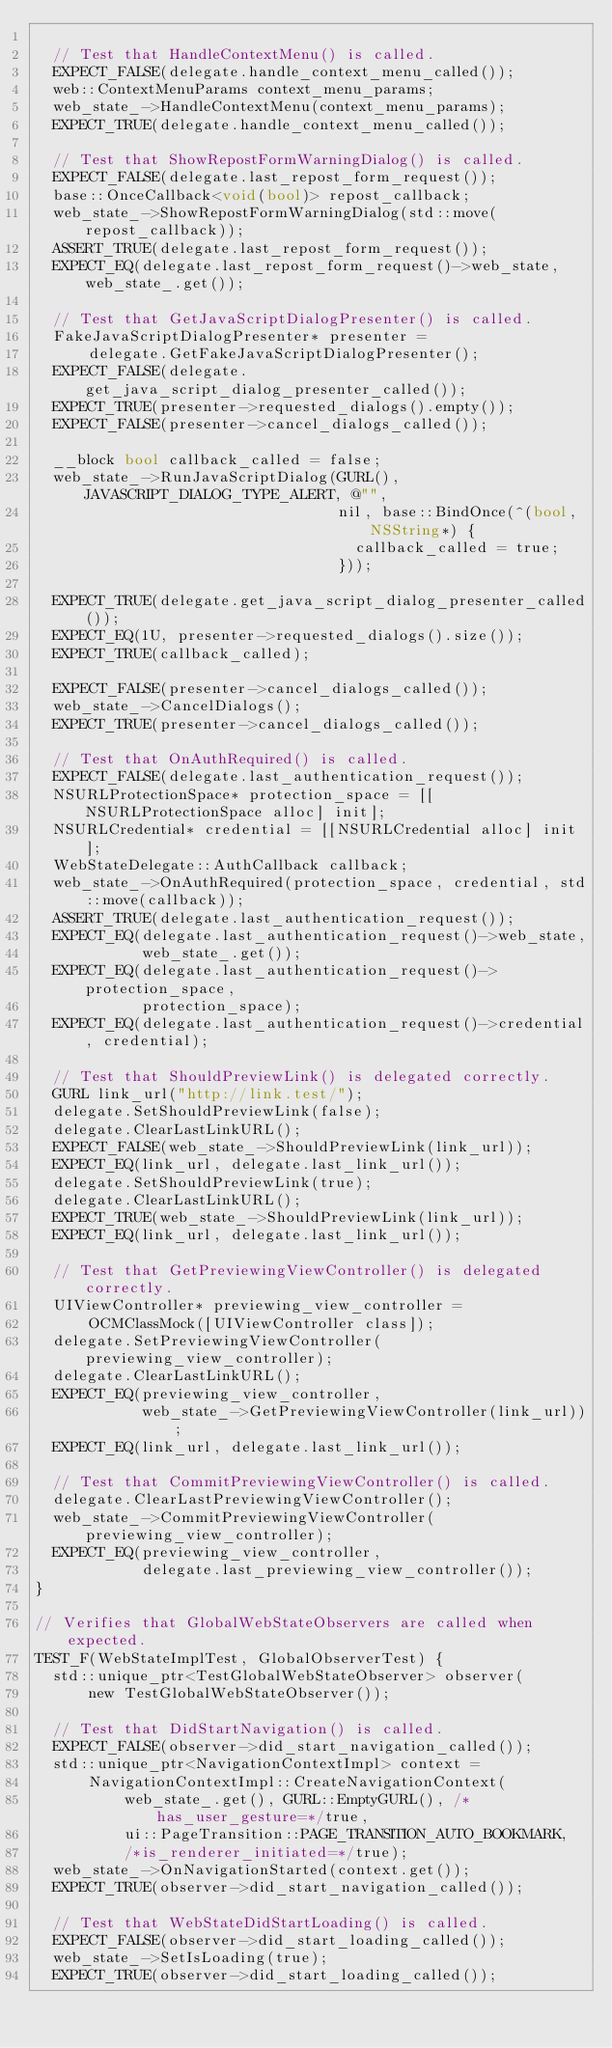<code> <loc_0><loc_0><loc_500><loc_500><_ObjectiveC_>
  // Test that HandleContextMenu() is called.
  EXPECT_FALSE(delegate.handle_context_menu_called());
  web::ContextMenuParams context_menu_params;
  web_state_->HandleContextMenu(context_menu_params);
  EXPECT_TRUE(delegate.handle_context_menu_called());

  // Test that ShowRepostFormWarningDialog() is called.
  EXPECT_FALSE(delegate.last_repost_form_request());
  base::OnceCallback<void(bool)> repost_callback;
  web_state_->ShowRepostFormWarningDialog(std::move(repost_callback));
  ASSERT_TRUE(delegate.last_repost_form_request());
  EXPECT_EQ(delegate.last_repost_form_request()->web_state, web_state_.get());

  // Test that GetJavaScriptDialogPresenter() is called.
  FakeJavaScriptDialogPresenter* presenter =
      delegate.GetFakeJavaScriptDialogPresenter();
  EXPECT_FALSE(delegate.get_java_script_dialog_presenter_called());
  EXPECT_TRUE(presenter->requested_dialogs().empty());
  EXPECT_FALSE(presenter->cancel_dialogs_called());

  __block bool callback_called = false;
  web_state_->RunJavaScriptDialog(GURL(), JAVASCRIPT_DIALOG_TYPE_ALERT, @"",
                                  nil, base::BindOnce(^(bool, NSString*) {
                                    callback_called = true;
                                  }));

  EXPECT_TRUE(delegate.get_java_script_dialog_presenter_called());
  EXPECT_EQ(1U, presenter->requested_dialogs().size());
  EXPECT_TRUE(callback_called);

  EXPECT_FALSE(presenter->cancel_dialogs_called());
  web_state_->CancelDialogs();
  EXPECT_TRUE(presenter->cancel_dialogs_called());

  // Test that OnAuthRequired() is called.
  EXPECT_FALSE(delegate.last_authentication_request());
  NSURLProtectionSpace* protection_space = [[NSURLProtectionSpace alloc] init];
  NSURLCredential* credential = [[NSURLCredential alloc] init];
  WebStateDelegate::AuthCallback callback;
  web_state_->OnAuthRequired(protection_space, credential, std::move(callback));
  ASSERT_TRUE(delegate.last_authentication_request());
  EXPECT_EQ(delegate.last_authentication_request()->web_state,
            web_state_.get());
  EXPECT_EQ(delegate.last_authentication_request()->protection_space,
            protection_space);
  EXPECT_EQ(delegate.last_authentication_request()->credential, credential);

  // Test that ShouldPreviewLink() is delegated correctly.
  GURL link_url("http://link.test/");
  delegate.SetShouldPreviewLink(false);
  delegate.ClearLastLinkURL();
  EXPECT_FALSE(web_state_->ShouldPreviewLink(link_url));
  EXPECT_EQ(link_url, delegate.last_link_url());
  delegate.SetShouldPreviewLink(true);
  delegate.ClearLastLinkURL();
  EXPECT_TRUE(web_state_->ShouldPreviewLink(link_url));
  EXPECT_EQ(link_url, delegate.last_link_url());

  // Test that GetPreviewingViewController() is delegated correctly.
  UIViewController* previewing_view_controller =
      OCMClassMock([UIViewController class]);
  delegate.SetPreviewingViewController(previewing_view_controller);
  delegate.ClearLastLinkURL();
  EXPECT_EQ(previewing_view_controller,
            web_state_->GetPreviewingViewController(link_url));
  EXPECT_EQ(link_url, delegate.last_link_url());

  // Test that CommitPreviewingViewController() is called.
  delegate.ClearLastPreviewingViewController();
  web_state_->CommitPreviewingViewController(previewing_view_controller);
  EXPECT_EQ(previewing_view_controller,
            delegate.last_previewing_view_controller());
}

// Verifies that GlobalWebStateObservers are called when expected.
TEST_F(WebStateImplTest, GlobalObserverTest) {
  std::unique_ptr<TestGlobalWebStateObserver> observer(
      new TestGlobalWebStateObserver());

  // Test that DidStartNavigation() is called.
  EXPECT_FALSE(observer->did_start_navigation_called());
  std::unique_ptr<NavigationContextImpl> context =
      NavigationContextImpl::CreateNavigationContext(
          web_state_.get(), GURL::EmptyGURL(), /*has_user_gesture=*/true,
          ui::PageTransition::PAGE_TRANSITION_AUTO_BOOKMARK,
          /*is_renderer_initiated=*/true);
  web_state_->OnNavigationStarted(context.get());
  EXPECT_TRUE(observer->did_start_navigation_called());

  // Test that WebStateDidStartLoading() is called.
  EXPECT_FALSE(observer->did_start_loading_called());
  web_state_->SetIsLoading(true);
  EXPECT_TRUE(observer->did_start_loading_called());
</code> 